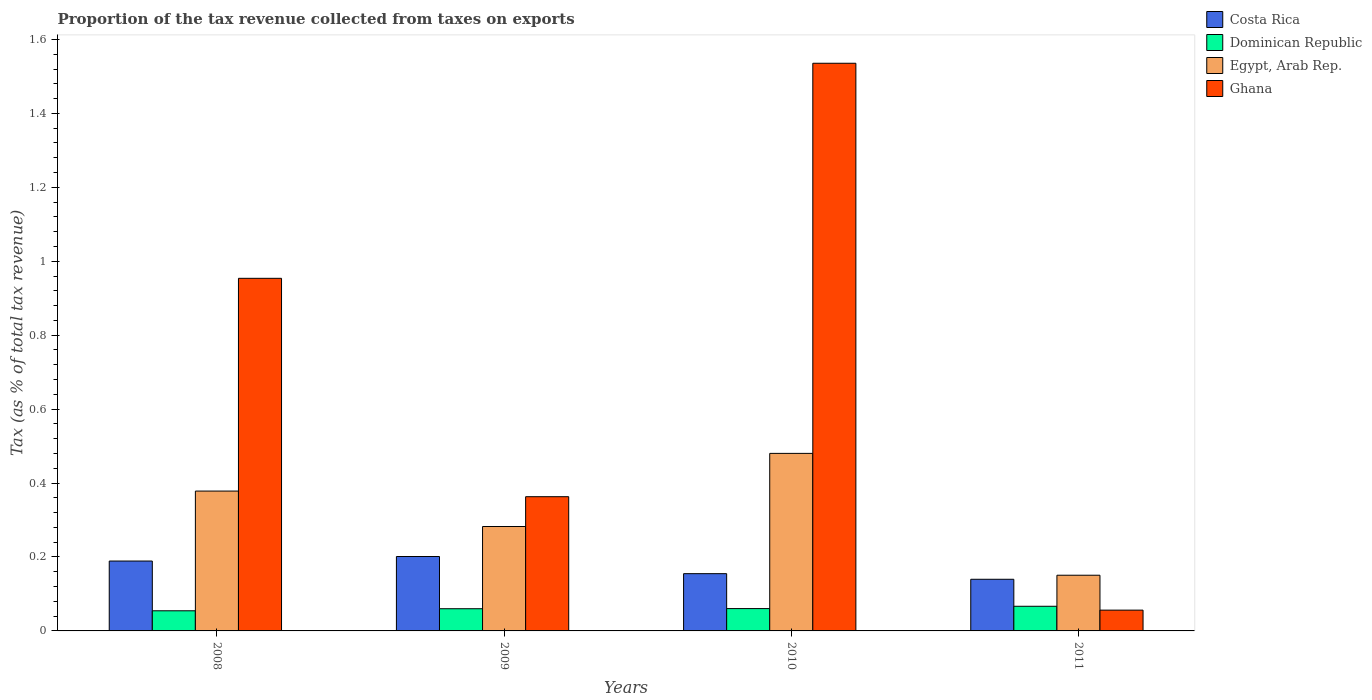How many different coloured bars are there?
Provide a short and direct response. 4. How many groups of bars are there?
Offer a very short reply. 4. Are the number of bars per tick equal to the number of legend labels?
Make the answer very short. Yes. How many bars are there on the 1st tick from the left?
Provide a succinct answer. 4. How many bars are there on the 2nd tick from the right?
Your answer should be compact. 4. In how many cases, is the number of bars for a given year not equal to the number of legend labels?
Provide a short and direct response. 0. What is the proportion of the tax revenue collected in Ghana in 2010?
Your answer should be very brief. 1.54. Across all years, what is the maximum proportion of the tax revenue collected in Dominican Republic?
Your answer should be very brief. 0.07. Across all years, what is the minimum proportion of the tax revenue collected in Egypt, Arab Rep.?
Your answer should be very brief. 0.15. What is the total proportion of the tax revenue collected in Egypt, Arab Rep. in the graph?
Make the answer very short. 1.29. What is the difference between the proportion of the tax revenue collected in Egypt, Arab Rep. in 2009 and that in 2011?
Keep it short and to the point. 0.13. What is the difference between the proportion of the tax revenue collected in Ghana in 2008 and the proportion of the tax revenue collected in Costa Rica in 2009?
Provide a short and direct response. 0.75. What is the average proportion of the tax revenue collected in Dominican Republic per year?
Offer a terse response. 0.06. In the year 2008, what is the difference between the proportion of the tax revenue collected in Costa Rica and proportion of the tax revenue collected in Egypt, Arab Rep.?
Your response must be concise. -0.19. In how many years, is the proportion of the tax revenue collected in Dominican Republic greater than 0.32 %?
Keep it short and to the point. 0. What is the ratio of the proportion of the tax revenue collected in Egypt, Arab Rep. in 2010 to that in 2011?
Your answer should be very brief. 3.19. Is the proportion of the tax revenue collected in Dominican Republic in 2008 less than that in 2010?
Offer a very short reply. Yes. What is the difference between the highest and the second highest proportion of the tax revenue collected in Egypt, Arab Rep.?
Provide a succinct answer. 0.1. What is the difference between the highest and the lowest proportion of the tax revenue collected in Egypt, Arab Rep.?
Ensure brevity in your answer.  0.33. In how many years, is the proportion of the tax revenue collected in Costa Rica greater than the average proportion of the tax revenue collected in Costa Rica taken over all years?
Your answer should be compact. 2. Is the sum of the proportion of the tax revenue collected in Ghana in 2008 and 2010 greater than the maximum proportion of the tax revenue collected in Dominican Republic across all years?
Make the answer very short. Yes. Is it the case that in every year, the sum of the proportion of the tax revenue collected in Ghana and proportion of the tax revenue collected in Dominican Republic is greater than the proportion of the tax revenue collected in Costa Rica?
Offer a terse response. No. Are all the bars in the graph horizontal?
Your answer should be compact. No. How many years are there in the graph?
Keep it short and to the point. 4. What is the difference between two consecutive major ticks on the Y-axis?
Your answer should be compact. 0.2. Are the values on the major ticks of Y-axis written in scientific E-notation?
Make the answer very short. No. Does the graph contain grids?
Your answer should be compact. No. Where does the legend appear in the graph?
Offer a very short reply. Top right. How many legend labels are there?
Your answer should be very brief. 4. What is the title of the graph?
Provide a short and direct response. Proportion of the tax revenue collected from taxes on exports. Does "South Sudan" appear as one of the legend labels in the graph?
Your answer should be compact. No. What is the label or title of the X-axis?
Your response must be concise. Years. What is the label or title of the Y-axis?
Give a very brief answer. Tax (as % of total tax revenue). What is the Tax (as % of total tax revenue) of Costa Rica in 2008?
Provide a succinct answer. 0.19. What is the Tax (as % of total tax revenue) of Dominican Republic in 2008?
Offer a terse response. 0.05. What is the Tax (as % of total tax revenue) of Egypt, Arab Rep. in 2008?
Keep it short and to the point. 0.38. What is the Tax (as % of total tax revenue) in Ghana in 2008?
Your answer should be very brief. 0.95. What is the Tax (as % of total tax revenue) of Costa Rica in 2009?
Make the answer very short. 0.2. What is the Tax (as % of total tax revenue) of Dominican Republic in 2009?
Offer a very short reply. 0.06. What is the Tax (as % of total tax revenue) of Egypt, Arab Rep. in 2009?
Offer a very short reply. 0.28. What is the Tax (as % of total tax revenue) in Ghana in 2009?
Provide a succinct answer. 0.36. What is the Tax (as % of total tax revenue) of Costa Rica in 2010?
Keep it short and to the point. 0.15. What is the Tax (as % of total tax revenue) of Dominican Republic in 2010?
Provide a succinct answer. 0.06. What is the Tax (as % of total tax revenue) of Egypt, Arab Rep. in 2010?
Provide a succinct answer. 0.48. What is the Tax (as % of total tax revenue) of Ghana in 2010?
Make the answer very short. 1.54. What is the Tax (as % of total tax revenue) in Costa Rica in 2011?
Your answer should be very brief. 0.14. What is the Tax (as % of total tax revenue) in Dominican Republic in 2011?
Your answer should be very brief. 0.07. What is the Tax (as % of total tax revenue) in Egypt, Arab Rep. in 2011?
Make the answer very short. 0.15. What is the Tax (as % of total tax revenue) in Ghana in 2011?
Offer a very short reply. 0.06. Across all years, what is the maximum Tax (as % of total tax revenue) of Costa Rica?
Keep it short and to the point. 0.2. Across all years, what is the maximum Tax (as % of total tax revenue) in Dominican Republic?
Your answer should be very brief. 0.07. Across all years, what is the maximum Tax (as % of total tax revenue) of Egypt, Arab Rep.?
Your answer should be very brief. 0.48. Across all years, what is the maximum Tax (as % of total tax revenue) of Ghana?
Offer a very short reply. 1.54. Across all years, what is the minimum Tax (as % of total tax revenue) of Costa Rica?
Provide a succinct answer. 0.14. Across all years, what is the minimum Tax (as % of total tax revenue) in Dominican Republic?
Your response must be concise. 0.05. Across all years, what is the minimum Tax (as % of total tax revenue) of Egypt, Arab Rep.?
Your answer should be compact. 0.15. Across all years, what is the minimum Tax (as % of total tax revenue) of Ghana?
Your answer should be very brief. 0.06. What is the total Tax (as % of total tax revenue) in Costa Rica in the graph?
Your answer should be compact. 0.68. What is the total Tax (as % of total tax revenue) of Dominican Republic in the graph?
Make the answer very short. 0.24. What is the total Tax (as % of total tax revenue) in Egypt, Arab Rep. in the graph?
Your answer should be very brief. 1.29. What is the total Tax (as % of total tax revenue) in Ghana in the graph?
Offer a very short reply. 2.91. What is the difference between the Tax (as % of total tax revenue) in Costa Rica in 2008 and that in 2009?
Provide a succinct answer. -0.01. What is the difference between the Tax (as % of total tax revenue) in Dominican Republic in 2008 and that in 2009?
Your response must be concise. -0.01. What is the difference between the Tax (as % of total tax revenue) in Egypt, Arab Rep. in 2008 and that in 2009?
Your answer should be compact. 0.1. What is the difference between the Tax (as % of total tax revenue) in Ghana in 2008 and that in 2009?
Give a very brief answer. 0.59. What is the difference between the Tax (as % of total tax revenue) of Costa Rica in 2008 and that in 2010?
Give a very brief answer. 0.03. What is the difference between the Tax (as % of total tax revenue) in Dominican Republic in 2008 and that in 2010?
Ensure brevity in your answer.  -0.01. What is the difference between the Tax (as % of total tax revenue) of Egypt, Arab Rep. in 2008 and that in 2010?
Offer a terse response. -0.1. What is the difference between the Tax (as % of total tax revenue) of Ghana in 2008 and that in 2010?
Make the answer very short. -0.58. What is the difference between the Tax (as % of total tax revenue) of Costa Rica in 2008 and that in 2011?
Your answer should be very brief. 0.05. What is the difference between the Tax (as % of total tax revenue) of Dominican Republic in 2008 and that in 2011?
Keep it short and to the point. -0.01. What is the difference between the Tax (as % of total tax revenue) in Egypt, Arab Rep. in 2008 and that in 2011?
Keep it short and to the point. 0.23. What is the difference between the Tax (as % of total tax revenue) of Ghana in 2008 and that in 2011?
Provide a short and direct response. 0.9. What is the difference between the Tax (as % of total tax revenue) of Costa Rica in 2009 and that in 2010?
Provide a short and direct response. 0.05. What is the difference between the Tax (as % of total tax revenue) of Dominican Republic in 2009 and that in 2010?
Your answer should be very brief. -0. What is the difference between the Tax (as % of total tax revenue) in Egypt, Arab Rep. in 2009 and that in 2010?
Keep it short and to the point. -0.2. What is the difference between the Tax (as % of total tax revenue) of Ghana in 2009 and that in 2010?
Keep it short and to the point. -1.17. What is the difference between the Tax (as % of total tax revenue) of Costa Rica in 2009 and that in 2011?
Your response must be concise. 0.06. What is the difference between the Tax (as % of total tax revenue) of Dominican Republic in 2009 and that in 2011?
Ensure brevity in your answer.  -0.01. What is the difference between the Tax (as % of total tax revenue) of Egypt, Arab Rep. in 2009 and that in 2011?
Ensure brevity in your answer.  0.13. What is the difference between the Tax (as % of total tax revenue) of Ghana in 2009 and that in 2011?
Ensure brevity in your answer.  0.31. What is the difference between the Tax (as % of total tax revenue) in Costa Rica in 2010 and that in 2011?
Make the answer very short. 0.02. What is the difference between the Tax (as % of total tax revenue) of Dominican Republic in 2010 and that in 2011?
Make the answer very short. -0.01. What is the difference between the Tax (as % of total tax revenue) in Egypt, Arab Rep. in 2010 and that in 2011?
Keep it short and to the point. 0.33. What is the difference between the Tax (as % of total tax revenue) in Ghana in 2010 and that in 2011?
Your response must be concise. 1.48. What is the difference between the Tax (as % of total tax revenue) in Costa Rica in 2008 and the Tax (as % of total tax revenue) in Dominican Republic in 2009?
Give a very brief answer. 0.13. What is the difference between the Tax (as % of total tax revenue) of Costa Rica in 2008 and the Tax (as % of total tax revenue) of Egypt, Arab Rep. in 2009?
Give a very brief answer. -0.09. What is the difference between the Tax (as % of total tax revenue) of Costa Rica in 2008 and the Tax (as % of total tax revenue) of Ghana in 2009?
Offer a very short reply. -0.17. What is the difference between the Tax (as % of total tax revenue) in Dominican Republic in 2008 and the Tax (as % of total tax revenue) in Egypt, Arab Rep. in 2009?
Ensure brevity in your answer.  -0.23. What is the difference between the Tax (as % of total tax revenue) in Dominican Republic in 2008 and the Tax (as % of total tax revenue) in Ghana in 2009?
Keep it short and to the point. -0.31. What is the difference between the Tax (as % of total tax revenue) of Egypt, Arab Rep. in 2008 and the Tax (as % of total tax revenue) of Ghana in 2009?
Give a very brief answer. 0.02. What is the difference between the Tax (as % of total tax revenue) of Costa Rica in 2008 and the Tax (as % of total tax revenue) of Dominican Republic in 2010?
Your response must be concise. 0.13. What is the difference between the Tax (as % of total tax revenue) of Costa Rica in 2008 and the Tax (as % of total tax revenue) of Egypt, Arab Rep. in 2010?
Ensure brevity in your answer.  -0.29. What is the difference between the Tax (as % of total tax revenue) in Costa Rica in 2008 and the Tax (as % of total tax revenue) in Ghana in 2010?
Your response must be concise. -1.35. What is the difference between the Tax (as % of total tax revenue) in Dominican Republic in 2008 and the Tax (as % of total tax revenue) in Egypt, Arab Rep. in 2010?
Make the answer very short. -0.43. What is the difference between the Tax (as % of total tax revenue) in Dominican Republic in 2008 and the Tax (as % of total tax revenue) in Ghana in 2010?
Give a very brief answer. -1.48. What is the difference between the Tax (as % of total tax revenue) of Egypt, Arab Rep. in 2008 and the Tax (as % of total tax revenue) of Ghana in 2010?
Your answer should be very brief. -1.16. What is the difference between the Tax (as % of total tax revenue) of Costa Rica in 2008 and the Tax (as % of total tax revenue) of Dominican Republic in 2011?
Give a very brief answer. 0.12. What is the difference between the Tax (as % of total tax revenue) in Costa Rica in 2008 and the Tax (as % of total tax revenue) in Egypt, Arab Rep. in 2011?
Give a very brief answer. 0.04. What is the difference between the Tax (as % of total tax revenue) in Costa Rica in 2008 and the Tax (as % of total tax revenue) in Ghana in 2011?
Offer a very short reply. 0.13. What is the difference between the Tax (as % of total tax revenue) of Dominican Republic in 2008 and the Tax (as % of total tax revenue) of Egypt, Arab Rep. in 2011?
Make the answer very short. -0.1. What is the difference between the Tax (as % of total tax revenue) of Dominican Republic in 2008 and the Tax (as % of total tax revenue) of Ghana in 2011?
Provide a short and direct response. -0. What is the difference between the Tax (as % of total tax revenue) of Egypt, Arab Rep. in 2008 and the Tax (as % of total tax revenue) of Ghana in 2011?
Offer a very short reply. 0.32. What is the difference between the Tax (as % of total tax revenue) of Costa Rica in 2009 and the Tax (as % of total tax revenue) of Dominican Republic in 2010?
Your answer should be compact. 0.14. What is the difference between the Tax (as % of total tax revenue) in Costa Rica in 2009 and the Tax (as % of total tax revenue) in Egypt, Arab Rep. in 2010?
Offer a terse response. -0.28. What is the difference between the Tax (as % of total tax revenue) of Costa Rica in 2009 and the Tax (as % of total tax revenue) of Ghana in 2010?
Give a very brief answer. -1.33. What is the difference between the Tax (as % of total tax revenue) in Dominican Republic in 2009 and the Tax (as % of total tax revenue) in Egypt, Arab Rep. in 2010?
Your answer should be very brief. -0.42. What is the difference between the Tax (as % of total tax revenue) in Dominican Republic in 2009 and the Tax (as % of total tax revenue) in Ghana in 2010?
Provide a short and direct response. -1.48. What is the difference between the Tax (as % of total tax revenue) in Egypt, Arab Rep. in 2009 and the Tax (as % of total tax revenue) in Ghana in 2010?
Offer a very short reply. -1.25. What is the difference between the Tax (as % of total tax revenue) of Costa Rica in 2009 and the Tax (as % of total tax revenue) of Dominican Republic in 2011?
Your response must be concise. 0.13. What is the difference between the Tax (as % of total tax revenue) in Costa Rica in 2009 and the Tax (as % of total tax revenue) in Egypt, Arab Rep. in 2011?
Your response must be concise. 0.05. What is the difference between the Tax (as % of total tax revenue) in Costa Rica in 2009 and the Tax (as % of total tax revenue) in Ghana in 2011?
Offer a terse response. 0.15. What is the difference between the Tax (as % of total tax revenue) in Dominican Republic in 2009 and the Tax (as % of total tax revenue) in Egypt, Arab Rep. in 2011?
Provide a short and direct response. -0.09. What is the difference between the Tax (as % of total tax revenue) of Dominican Republic in 2009 and the Tax (as % of total tax revenue) of Ghana in 2011?
Your answer should be compact. 0. What is the difference between the Tax (as % of total tax revenue) of Egypt, Arab Rep. in 2009 and the Tax (as % of total tax revenue) of Ghana in 2011?
Provide a short and direct response. 0.23. What is the difference between the Tax (as % of total tax revenue) of Costa Rica in 2010 and the Tax (as % of total tax revenue) of Dominican Republic in 2011?
Your answer should be very brief. 0.09. What is the difference between the Tax (as % of total tax revenue) in Costa Rica in 2010 and the Tax (as % of total tax revenue) in Egypt, Arab Rep. in 2011?
Your answer should be compact. 0. What is the difference between the Tax (as % of total tax revenue) in Costa Rica in 2010 and the Tax (as % of total tax revenue) in Ghana in 2011?
Keep it short and to the point. 0.1. What is the difference between the Tax (as % of total tax revenue) in Dominican Republic in 2010 and the Tax (as % of total tax revenue) in Egypt, Arab Rep. in 2011?
Keep it short and to the point. -0.09. What is the difference between the Tax (as % of total tax revenue) in Dominican Republic in 2010 and the Tax (as % of total tax revenue) in Ghana in 2011?
Provide a succinct answer. 0. What is the difference between the Tax (as % of total tax revenue) of Egypt, Arab Rep. in 2010 and the Tax (as % of total tax revenue) of Ghana in 2011?
Offer a very short reply. 0.42. What is the average Tax (as % of total tax revenue) of Costa Rica per year?
Provide a succinct answer. 0.17. What is the average Tax (as % of total tax revenue) of Dominican Republic per year?
Keep it short and to the point. 0.06. What is the average Tax (as % of total tax revenue) of Egypt, Arab Rep. per year?
Give a very brief answer. 0.32. What is the average Tax (as % of total tax revenue) in Ghana per year?
Your answer should be very brief. 0.73. In the year 2008, what is the difference between the Tax (as % of total tax revenue) in Costa Rica and Tax (as % of total tax revenue) in Dominican Republic?
Ensure brevity in your answer.  0.13. In the year 2008, what is the difference between the Tax (as % of total tax revenue) in Costa Rica and Tax (as % of total tax revenue) in Egypt, Arab Rep.?
Offer a very short reply. -0.19. In the year 2008, what is the difference between the Tax (as % of total tax revenue) in Costa Rica and Tax (as % of total tax revenue) in Ghana?
Give a very brief answer. -0.76. In the year 2008, what is the difference between the Tax (as % of total tax revenue) of Dominican Republic and Tax (as % of total tax revenue) of Egypt, Arab Rep.?
Provide a short and direct response. -0.32. In the year 2008, what is the difference between the Tax (as % of total tax revenue) of Dominican Republic and Tax (as % of total tax revenue) of Ghana?
Make the answer very short. -0.9. In the year 2008, what is the difference between the Tax (as % of total tax revenue) in Egypt, Arab Rep. and Tax (as % of total tax revenue) in Ghana?
Your answer should be compact. -0.58. In the year 2009, what is the difference between the Tax (as % of total tax revenue) in Costa Rica and Tax (as % of total tax revenue) in Dominican Republic?
Provide a short and direct response. 0.14. In the year 2009, what is the difference between the Tax (as % of total tax revenue) in Costa Rica and Tax (as % of total tax revenue) in Egypt, Arab Rep.?
Give a very brief answer. -0.08. In the year 2009, what is the difference between the Tax (as % of total tax revenue) of Costa Rica and Tax (as % of total tax revenue) of Ghana?
Ensure brevity in your answer.  -0.16. In the year 2009, what is the difference between the Tax (as % of total tax revenue) of Dominican Republic and Tax (as % of total tax revenue) of Egypt, Arab Rep.?
Your answer should be compact. -0.22. In the year 2009, what is the difference between the Tax (as % of total tax revenue) of Dominican Republic and Tax (as % of total tax revenue) of Ghana?
Offer a very short reply. -0.3. In the year 2009, what is the difference between the Tax (as % of total tax revenue) in Egypt, Arab Rep. and Tax (as % of total tax revenue) in Ghana?
Ensure brevity in your answer.  -0.08. In the year 2010, what is the difference between the Tax (as % of total tax revenue) in Costa Rica and Tax (as % of total tax revenue) in Dominican Republic?
Your response must be concise. 0.09. In the year 2010, what is the difference between the Tax (as % of total tax revenue) in Costa Rica and Tax (as % of total tax revenue) in Egypt, Arab Rep.?
Provide a short and direct response. -0.33. In the year 2010, what is the difference between the Tax (as % of total tax revenue) of Costa Rica and Tax (as % of total tax revenue) of Ghana?
Keep it short and to the point. -1.38. In the year 2010, what is the difference between the Tax (as % of total tax revenue) of Dominican Republic and Tax (as % of total tax revenue) of Egypt, Arab Rep.?
Keep it short and to the point. -0.42. In the year 2010, what is the difference between the Tax (as % of total tax revenue) of Dominican Republic and Tax (as % of total tax revenue) of Ghana?
Give a very brief answer. -1.48. In the year 2010, what is the difference between the Tax (as % of total tax revenue) of Egypt, Arab Rep. and Tax (as % of total tax revenue) of Ghana?
Your answer should be compact. -1.06. In the year 2011, what is the difference between the Tax (as % of total tax revenue) in Costa Rica and Tax (as % of total tax revenue) in Dominican Republic?
Make the answer very short. 0.07. In the year 2011, what is the difference between the Tax (as % of total tax revenue) in Costa Rica and Tax (as % of total tax revenue) in Egypt, Arab Rep.?
Provide a short and direct response. -0.01. In the year 2011, what is the difference between the Tax (as % of total tax revenue) of Costa Rica and Tax (as % of total tax revenue) of Ghana?
Make the answer very short. 0.08. In the year 2011, what is the difference between the Tax (as % of total tax revenue) of Dominican Republic and Tax (as % of total tax revenue) of Egypt, Arab Rep.?
Make the answer very short. -0.08. In the year 2011, what is the difference between the Tax (as % of total tax revenue) in Dominican Republic and Tax (as % of total tax revenue) in Ghana?
Your answer should be compact. 0.01. In the year 2011, what is the difference between the Tax (as % of total tax revenue) in Egypt, Arab Rep. and Tax (as % of total tax revenue) in Ghana?
Provide a succinct answer. 0.09. What is the ratio of the Tax (as % of total tax revenue) of Costa Rica in 2008 to that in 2009?
Offer a terse response. 0.94. What is the ratio of the Tax (as % of total tax revenue) in Dominican Republic in 2008 to that in 2009?
Keep it short and to the point. 0.91. What is the ratio of the Tax (as % of total tax revenue) of Egypt, Arab Rep. in 2008 to that in 2009?
Ensure brevity in your answer.  1.34. What is the ratio of the Tax (as % of total tax revenue) in Ghana in 2008 to that in 2009?
Provide a short and direct response. 2.63. What is the ratio of the Tax (as % of total tax revenue) of Costa Rica in 2008 to that in 2010?
Make the answer very short. 1.22. What is the ratio of the Tax (as % of total tax revenue) of Dominican Republic in 2008 to that in 2010?
Ensure brevity in your answer.  0.9. What is the ratio of the Tax (as % of total tax revenue) in Egypt, Arab Rep. in 2008 to that in 2010?
Ensure brevity in your answer.  0.79. What is the ratio of the Tax (as % of total tax revenue) in Ghana in 2008 to that in 2010?
Your answer should be compact. 0.62. What is the ratio of the Tax (as % of total tax revenue) of Costa Rica in 2008 to that in 2011?
Your answer should be compact. 1.35. What is the ratio of the Tax (as % of total tax revenue) in Dominican Republic in 2008 to that in 2011?
Your answer should be very brief. 0.82. What is the ratio of the Tax (as % of total tax revenue) of Egypt, Arab Rep. in 2008 to that in 2011?
Make the answer very short. 2.51. What is the ratio of the Tax (as % of total tax revenue) of Ghana in 2008 to that in 2011?
Your answer should be compact. 16.96. What is the ratio of the Tax (as % of total tax revenue) of Costa Rica in 2009 to that in 2010?
Offer a very short reply. 1.3. What is the ratio of the Tax (as % of total tax revenue) of Egypt, Arab Rep. in 2009 to that in 2010?
Offer a very short reply. 0.59. What is the ratio of the Tax (as % of total tax revenue) of Ghana in 2009 to that in 2010?
Your answer should be compact. 0.24. What is the ratio of the Tax (as % of total tax revenue) of Costa Rica in 2009 to that in 2011?
Your answer should be very brief. 1.44. What is the ratio of the Tax (as % of total tax revenue) in Dominican Republic in 2009 to that in 2011?
Keep it short and to the point. 0.9. What is the ratio of the Tax (as % of total tax revenue) of Egypt, Arab Rep. in 2009 to that in 2011?
Your response must be concise. 1.87. What is the ratio of the Tax (as % of total tax revenue) in Ghana in 2009 to that in 2011?
Ensure brevity in your answer.  6.46. What is the ratio of the Tax (as % of total tax revenue) of Costa Rica in 2010 to that in 2011?
Offer a very short reply. 1.11. What is the ratio of the Tax (as % of total tax revenue) of Dominican Republic in 2010 to that in 2011?
Your answer should be compact. 0.91. What is the ratio of the Tax (as % of total tax revenue) in Egypt, Arab Rep. in 2010 to that in 2011?
Ensure brevity in your answer.  3.19. What is the ratio of the Tax (as % of total tax revenue) in Ghana in 2010 to that in 2011?
Your answer should be very brief. 27.31. What is the difference between the highest and the second highest Tax (as % of total tax revenue) in Costa Rica?
Your answer should be compact. 0.01. What is the difference between the highest and the second highest Tax (as % of total tax revenue) of Dominican Republic?
Ensure brevity in your answer.  0.01. What is the difference between the highest and the second highest Tax (as % of total tax revenue) in Egypt, Arab Rep.?
Keep it short and to the point. 0.1. What is the difference between the highest and the second highest Tax (as % of total tax revenue) of Ghana?
Provide a succinct answer. 0.58. What is the difference between the highest and the lowest Tax (as % of total tax revenue) of Costa Rica?
Your answer should be compact. 0.06. What is the difference between the highest and the lowest Tax (as % of total tax revenue) in Dominican Republic?
Offer a terse response. 0.01. What is the difference between the highest and the lowest Tax (as % of total tax revenue) in Egypt, Arab Rep.?
Make the answer very short. 0.33. What is the difference between the highest and the lowest Tax (as % of total tax revenue) in Ghana?
Your answer should be compact. 1.48. 